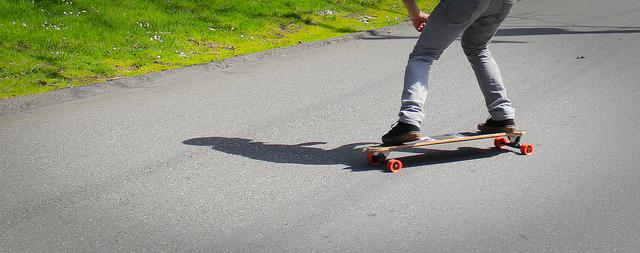What is the name of the sport being shown?
Answer briefly. Skateboarding. Is there a road and grass here?
Short answer required. Yes. Is he doing a trick?
Keep it brief. No. How many wheels are on the skateboard?
Answer briefly. 4. 